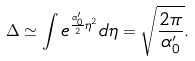Convert formula to latex. <formula><loc_0><loc_0><loc_500><loc_500>\Delta \simeq \int e ^ { \frac { \alpha ^ { \prime } _ { 0 } } { 2 } \eta ^ { 2 } } d \eta = \sqrt { \frac { 2 \pi } { \alpha ^ { \prime } _ { 0 } } } .</formula> 